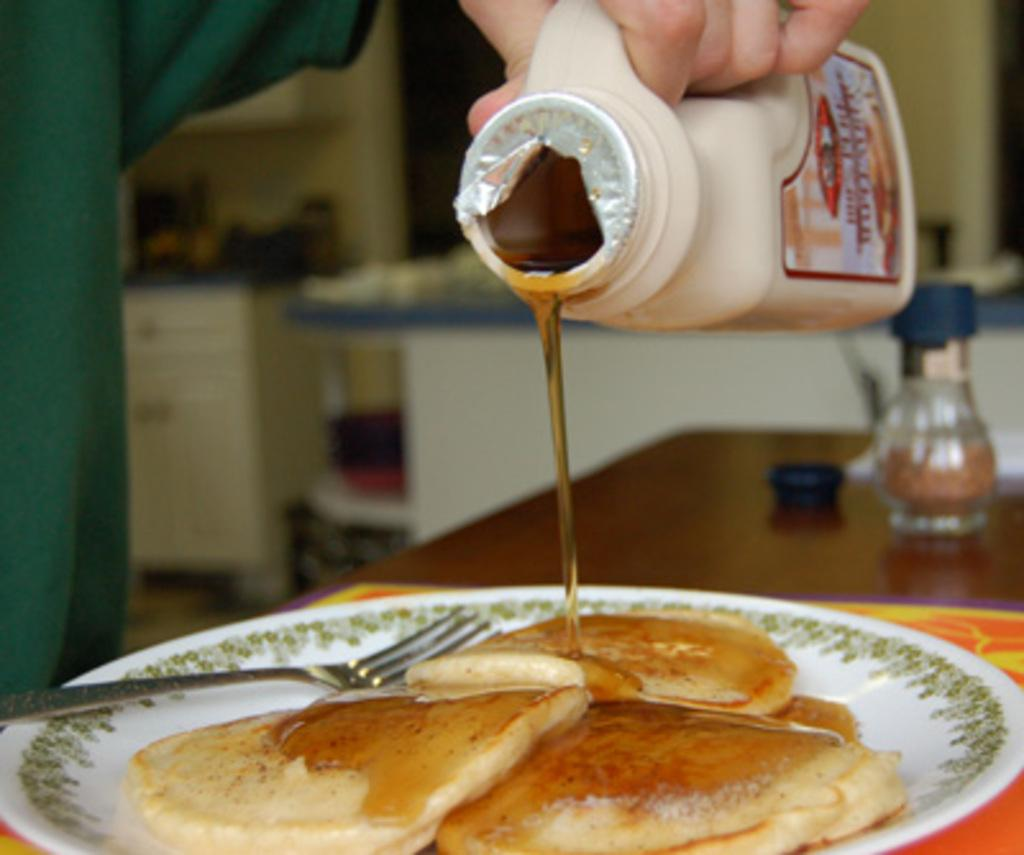What type of food items can be seen in the image? There are breads in the image. What utensil is present in the image? There is a fork in the image. What accompaniment is visible in the image? There is a honey bottle in the image. Reasoning: Let' Let's think step by step in order to produce the conversation. We start by identifying the main food items in the image, which are the breads. Then, we mention the utensil that is present, which is the fork. Finally, we describe the accompaniment that can be seen, which is the honey bottle. Each question is designed to elicit a specific detail about the image that is known from the provided facts. Absurd Question/Answer: How many boats can be seen sailing in the image? There are no boats present in the image. Is there a train visible in the image? There is no train present in the image. 